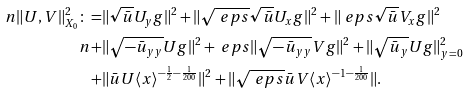<formula> <loc_0><loc_0><loc_500><loc_500>\ n \| U , V \| _ { X _ { 0 } } ^ { 2 } \colon = & \| \sqrt { \bar { u } } U _ { y } g \| ^ { 2 } + \| \sqrt { \ e p s } \sqrt { \bar { u } } U _ { x } g \| ^ { 2 } + \| \ e p s \sqrt { \bar { u } } V _ { x } g \| ^ { 2 } \\ \ n + & \| \sqrt { - \bar { u } _ { y y } } U g \| ^ { 2 } + \ e p s \| \sqrt { - \bar { u } _ { y y } } V g \| ^ { 2 } + \| \sqrt { \bar { u } _ { y } } U g \| _ { y = 0 } ^ { 2 } \\ + & \| \bar { u } U \langle x \rangle ^ { - \frac { 1 } { 2 } - \frac { 1 } { 2 0 0 } } \| ^ { 2 } + \| \sqrt { \ e p s } \bar { u } V \langle x \rangle ^ { - 1 - \frac { 1 } { 2 0 0 } } \| .</formula> 